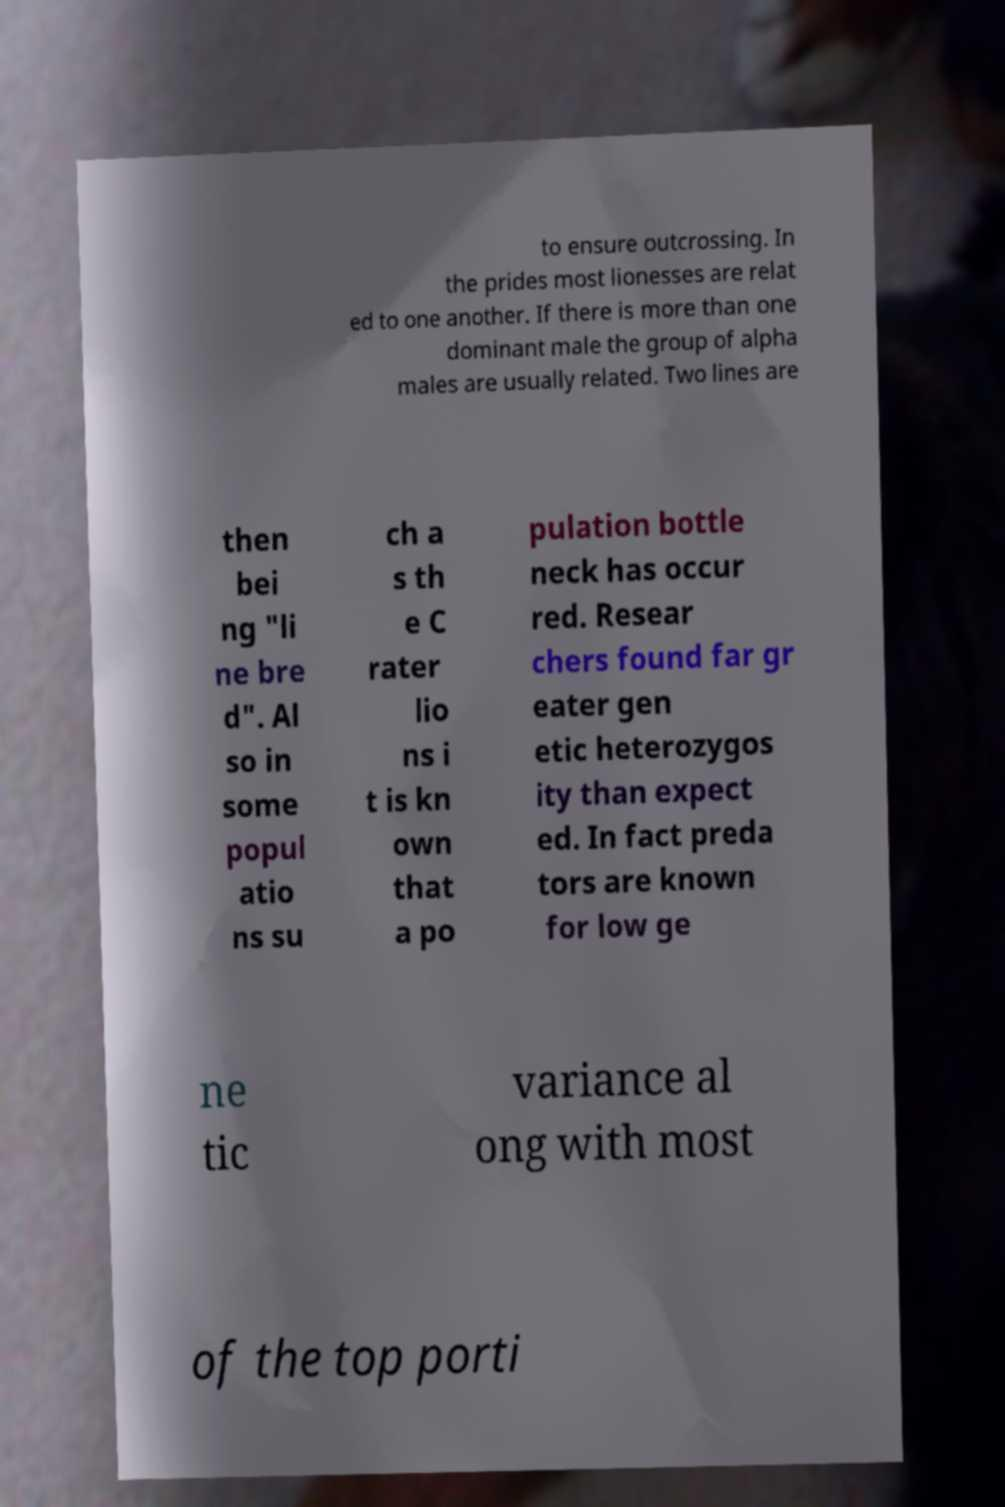There's text embedded in this image that I need extracted. Can you transcribe it verbatim? to ensure outcrossing. In the prides most lionesses are relat ed to one another. If there is more than one dominant male the group of alpha males are usually related. Two lines are then bei ng "li ne bre d". Al so in some popul atio ns su ch a s th e C rater lio ns i t is kn own that a po pulation bottle neck has occur red. Resear chers found far gr eater gen etic heterozygos ity than expect ed. In fact preda tors are known for low ge ne tic variance al ong with most of the top porti 